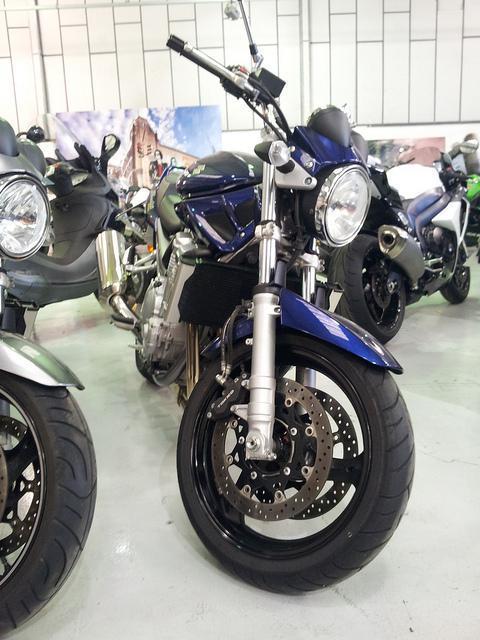How many motorcycles are there?
Give a very brief answer. 3. How many beds are under the lamp?
Give a very brief answer. 0. 